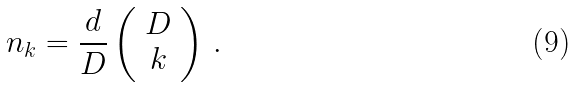Convert formula to latex. <formula><loc_0><loc_0><loc_500><loc_500>n _ { k } = \frac { d } { D } \left ( \begin{array} { c } D \\ k \end{array} \right ) \, .</formula> 